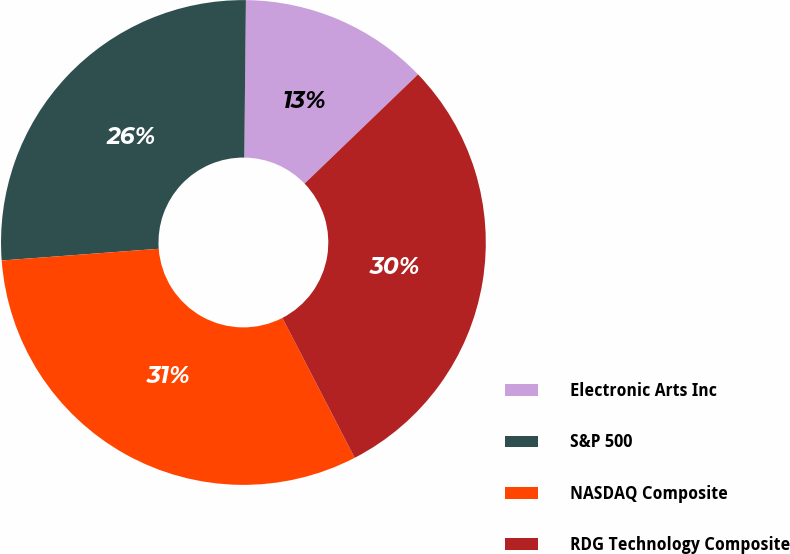<chart> <loc_0><loc_0><loc_500><loc_500><pie_chart><fcel>Electronic Arts Inc<fcel>S&P 500<fcel>NASDAQ Composite<fcel>RDG Technology Composite<nl><fcel>12.64%<fcel>26.35%<fcel>31.41%<fcel>29.6%<nl></chart> 